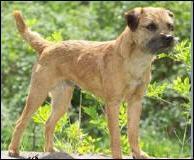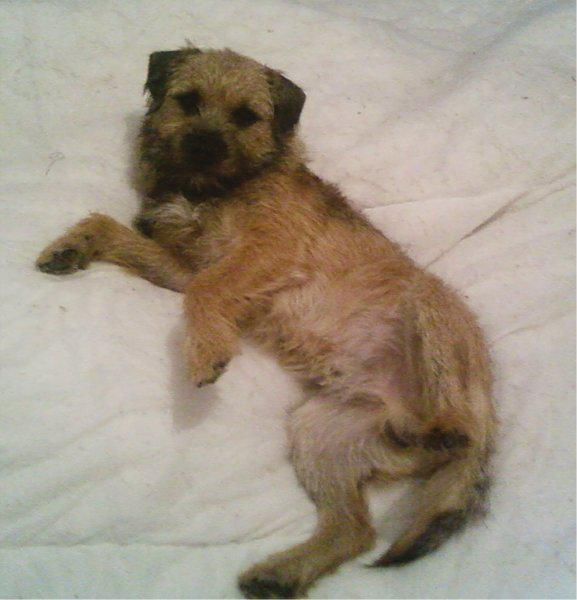The first image is the image on the left, the second image is the image on the right. Considering the images on both sides, is "The left and right image contains the same number of dogs with at least one standing." valid? Answer yes or no. Yes. The first image is the image on the left, the second image is the image on the right. Analyze the images presented: Is the assertion "The right image features one dog reclining on something soft and looking at the camera, and the left image shows a dog in an upright pose." valid? Answer yes or no. Yes. 